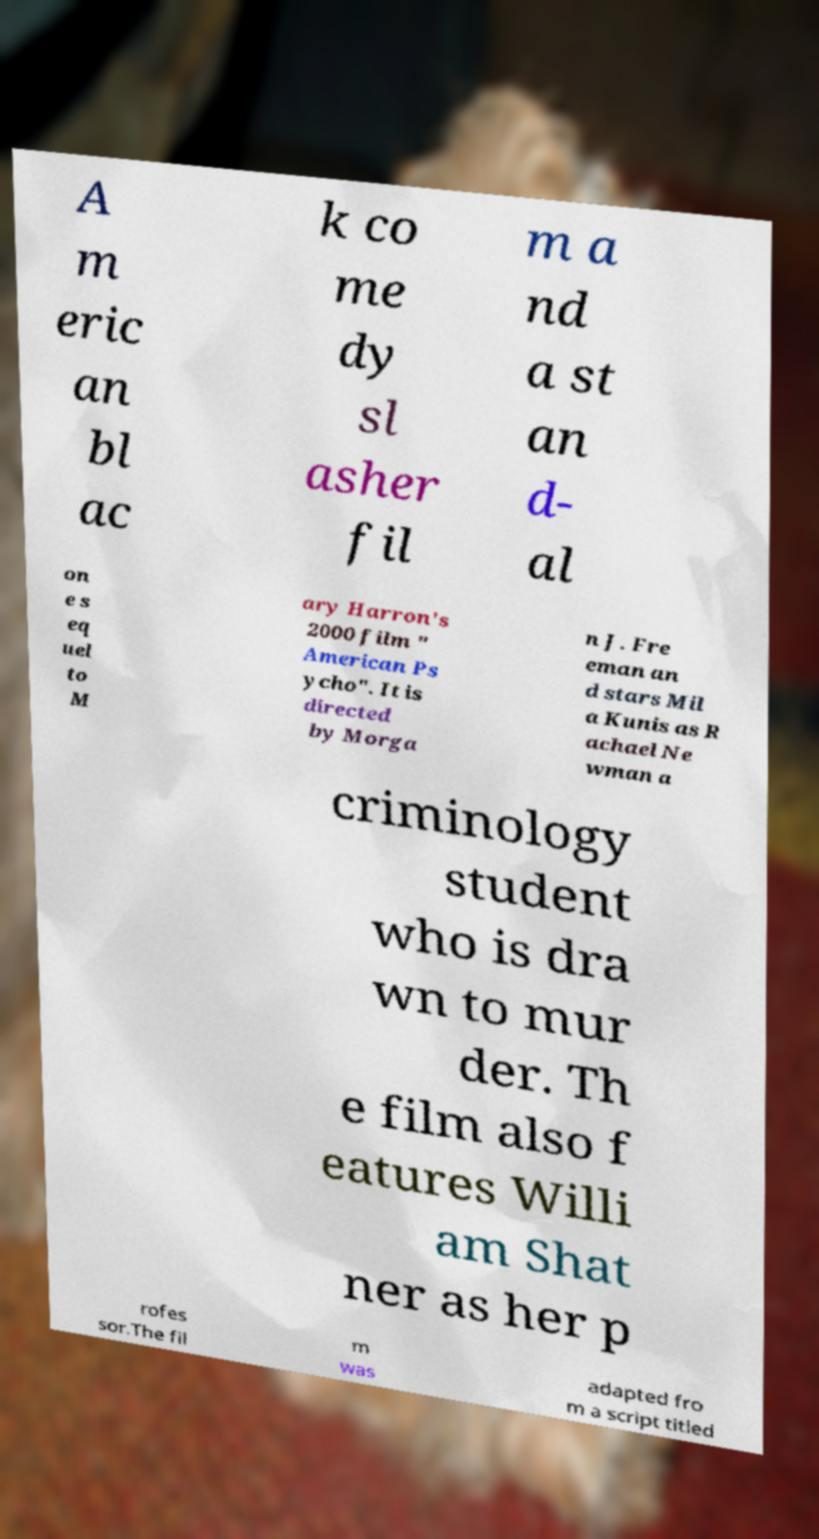Could you assist in decoding the text presented in this image and type it out clearly? A m eric an bl ac k co me dy sl asher fil m a nd a st an d- al on e s eq uel to M ary Harron's 2000 film " American Ps ycho". It is directed by Morga n J. Fre eman an d stars Mil a Kunis as R achael Ne wman a criminology student who is dra wn to mur der. Th e film also f eatures Willi am Shat ner as her p rofes sor.The fil m was adapted fro m a script titled 